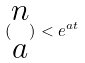Convert formula to latex. <formula><loc_0><loc_0><loc_500><loc_500>( \begin{matrix} n \\ a \end{matrix} ) < e ^ { a t }</formula> 